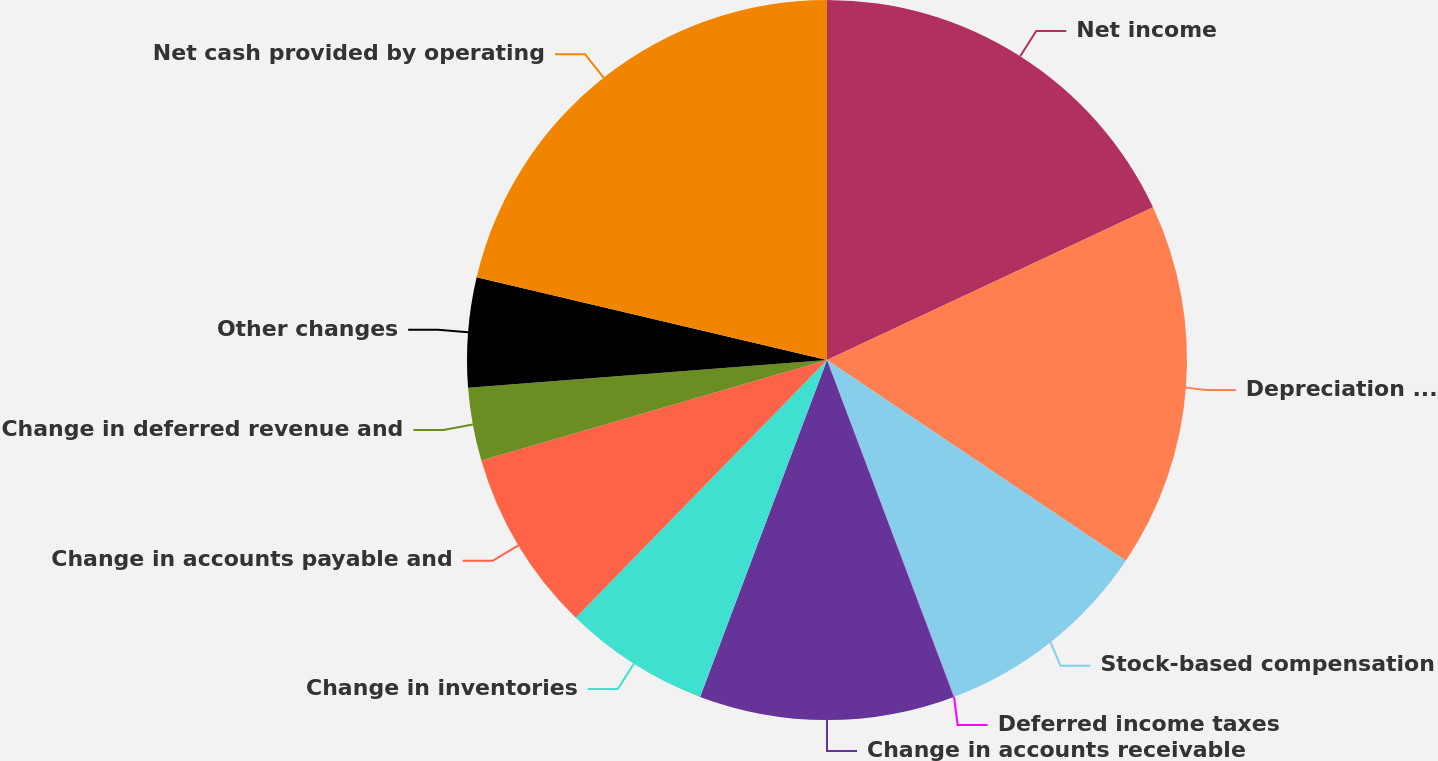Convert chart. <chart><loc_0><loc_0><loc_500><loc_500><pie_chart><fcel>Net income<fcel>Depreciation and amortization<fcel>Stock-based compensation<fcel>Deferred income taxes<fcel>Change in accounts receivable<fcel>Change in inventories<fcel>Change in accounts payable and<fcel>Change in deferred revenue and<fcel>Other changes<fcel>Net cash provided by operating<nl><fcel>18.03%<fcel>16.39%<fcel>9.84%<fcel>0.01%<fcel>11.47%<fcel>6.56%<fcel>8.2%<fcel>3.28%<fcel>4.92%<fcel>21.31%<nl></chart> 